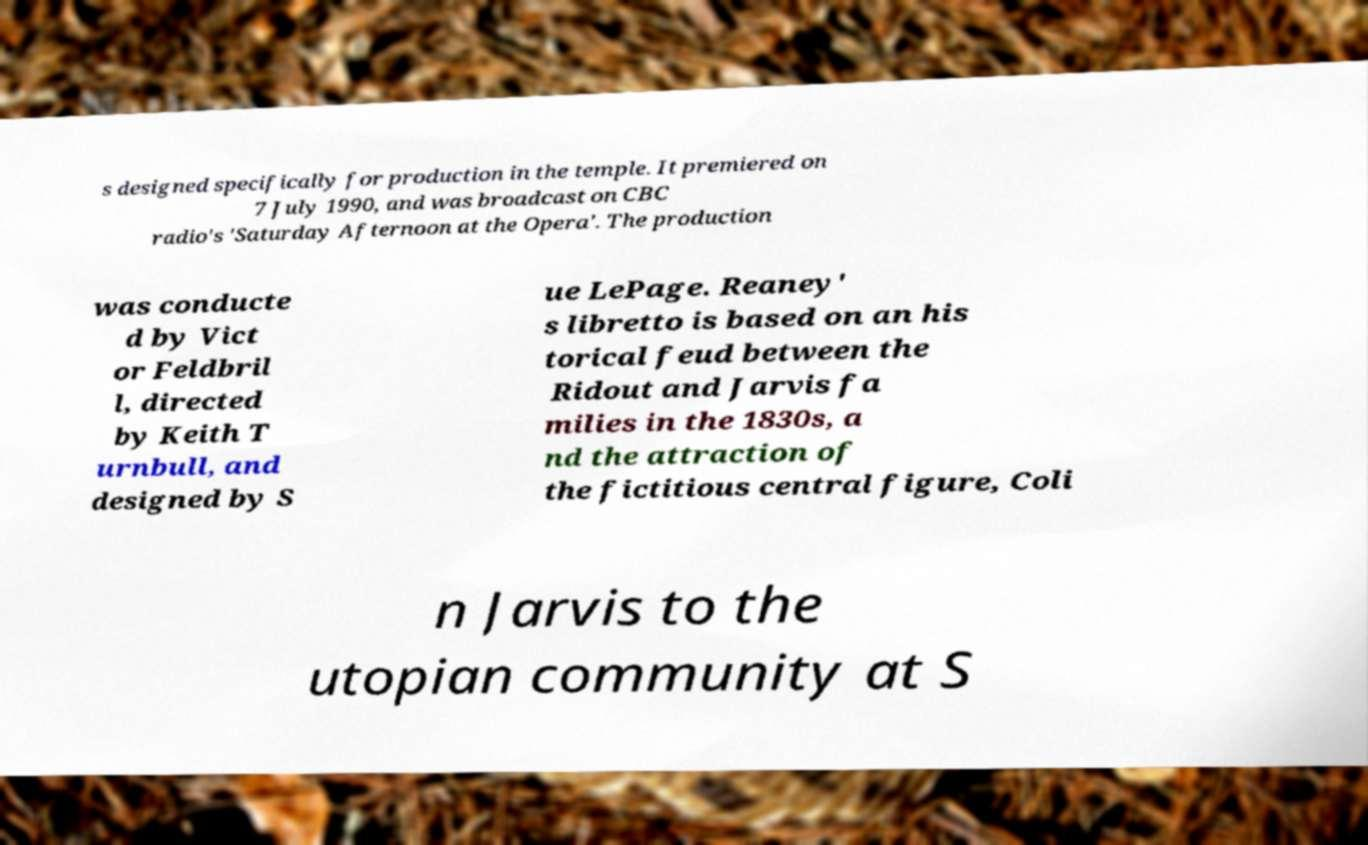For documentation purposes, I need the text within this image transcribed. Could you provide that? s designed specifically for production in the temple. It premiered on 7 July 1990, and was broadcast on CBC radio's 'Saturday Afternoon at the Opera'. The production was conducte d by Vict or Feldbril l, directed by Keith T urnbull, and designed by S ue LePage. Reaney' s libretto is based on an his torical feud between the Ridout and Jarvis fa milies in the 1830s, a nd the attraction of the fictitious central figure, Coli n Jarvis to the utopian community at S 